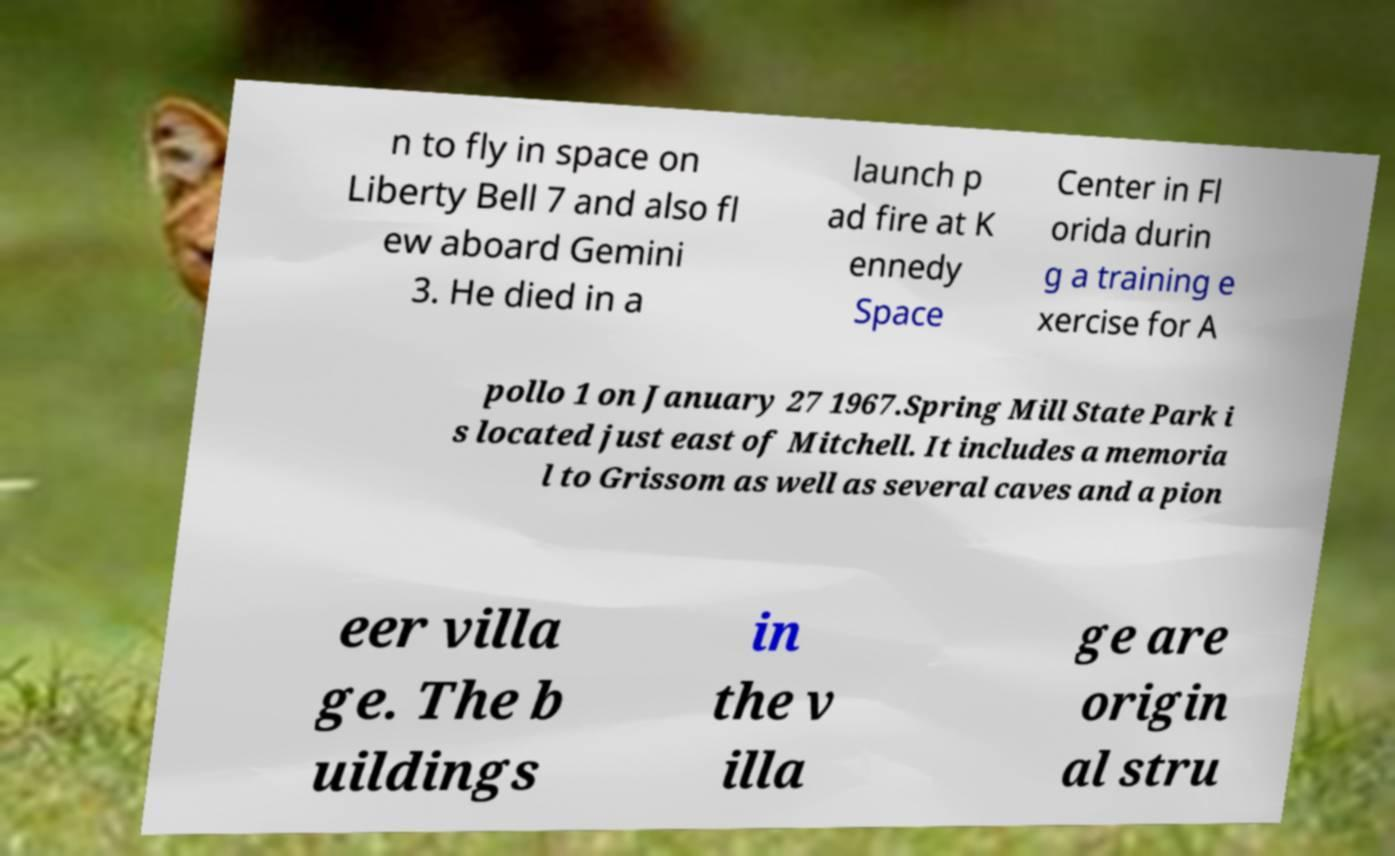Could you extract and type out the text from this image? n to fly in space on Liberty Bell 7 and also fl ew aboard Gemini 3. He died in a launch p ad fire at K ennedy Space Center in Fl orida durin g a training e xercise for A pollo 1 on January 27 1967.Spring Mill State Park i s located just east of Mitchell. It includes a memoria l to Grissom as well as several caves and a pion eer villa ge. The b uildings in the v illa ge are origin al stru 